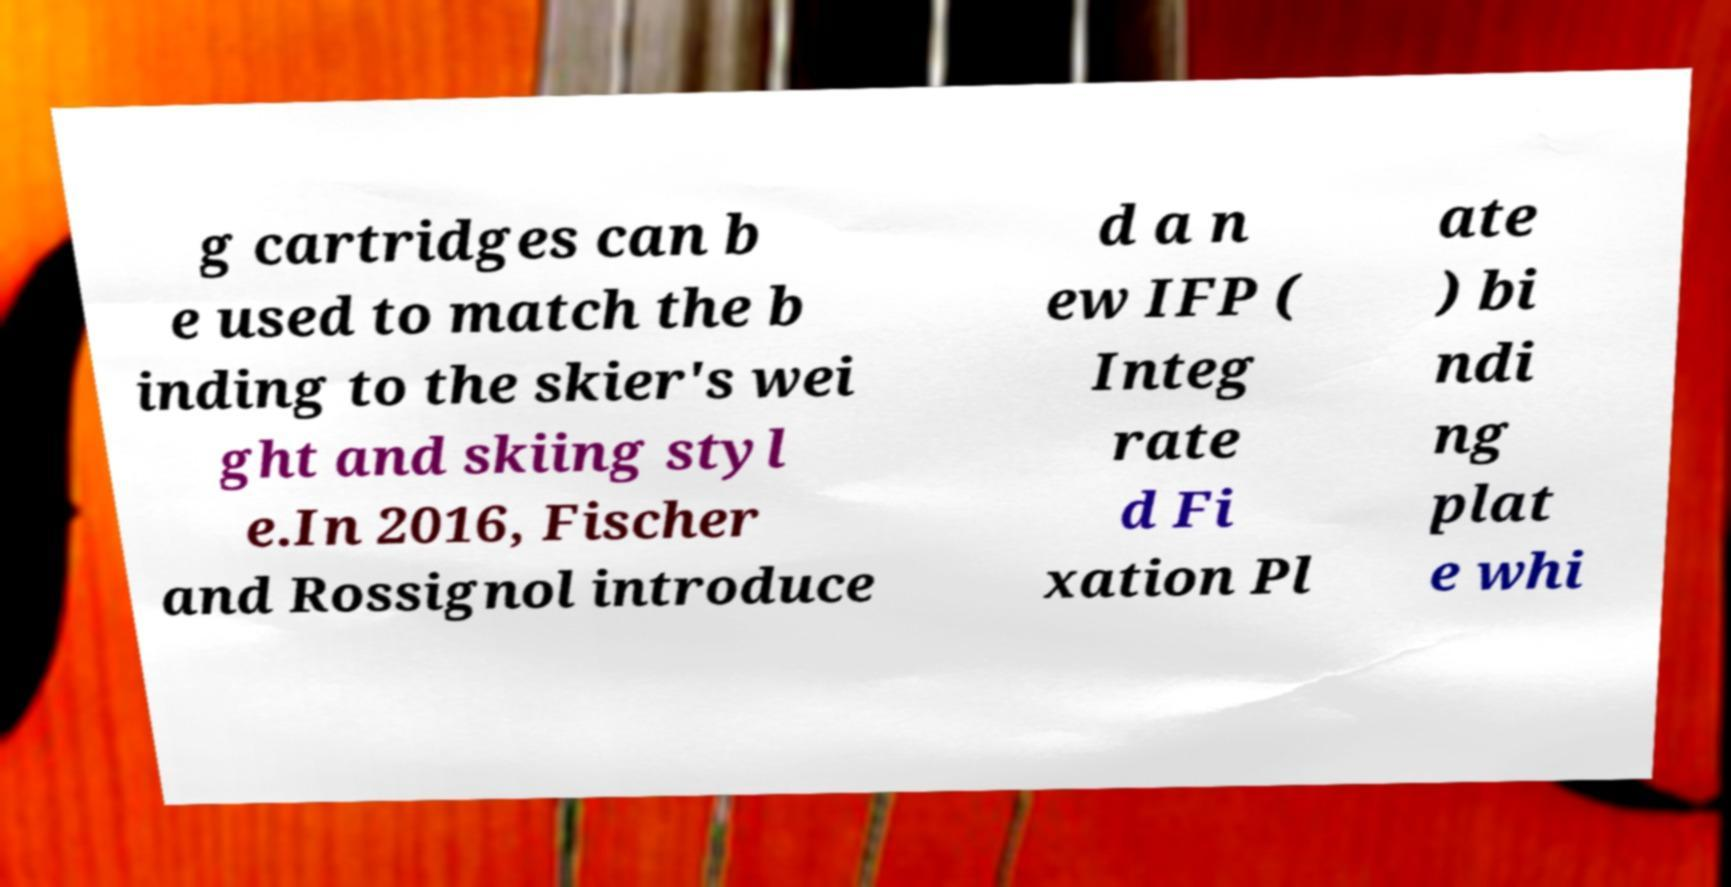What messages or text are displayed in this image? I need them in a readable, typed format. g cartridges can b e used to match the b inding to the skier's wei ght and skiing styl e.In 2016, Fischer and Rossignol introduce d a n ew IFP ( Integ rate d Fi xation Pl ate ) bi ndi ng plat e whi 